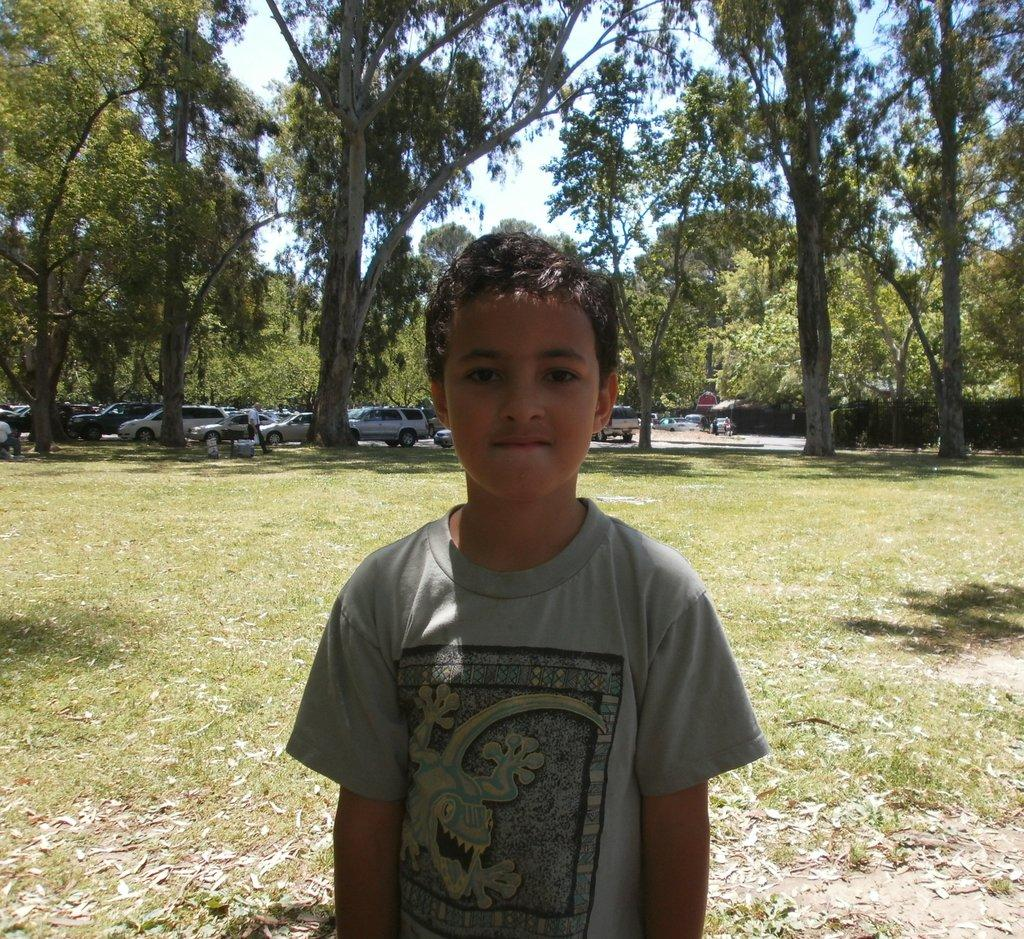Who is the main subject in the image? There is a boy in the image. Are there any other people in the image besides the boy? Yes, there are other persons behind the boy. What else can be seen in the image besides people? Vehicles, trees, the sky, and leaves on the ground are visible in the image. How many brothers does the boy have in the image? There is no information about the boy's brothers in the image. 